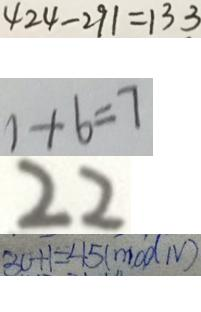<formula> <loc_0><loc_0><loc_500><loc_500>4 2 4 - 2 9 1 = 1 3 3 
 1 + 6 = 7 
 2 2 
 3 0 + 1 = 4 5 ( m o d N )</formula> 